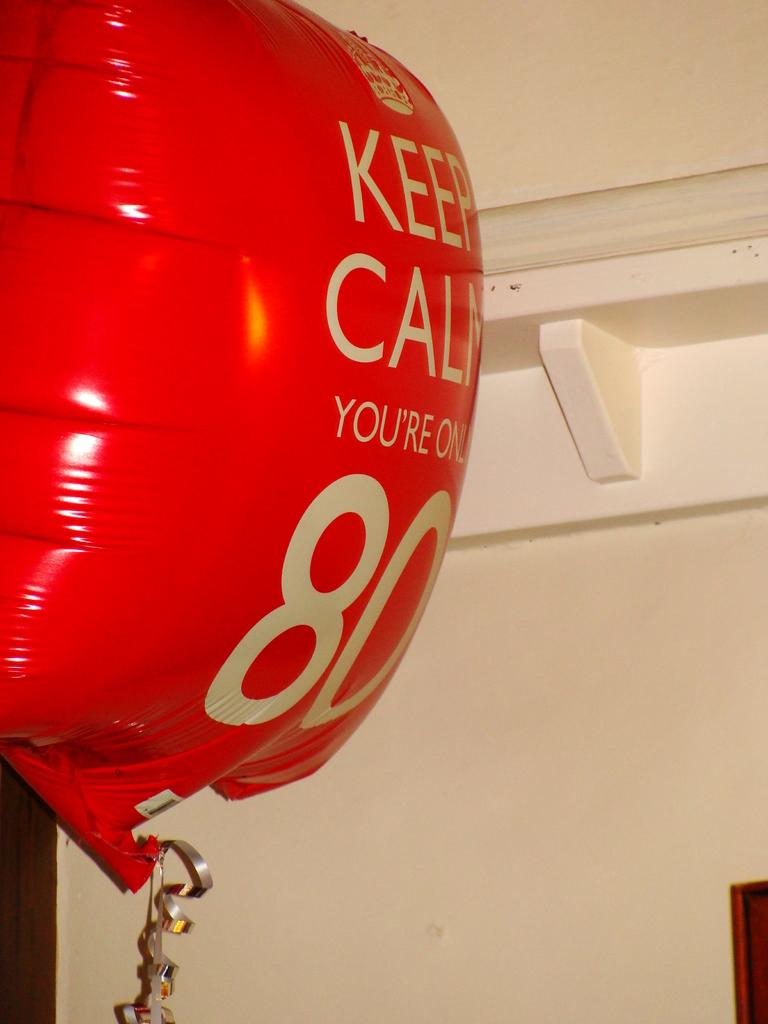<image>
Give a short and clear explanation of the subsequent image. A red balloon has the number 80 on it. 